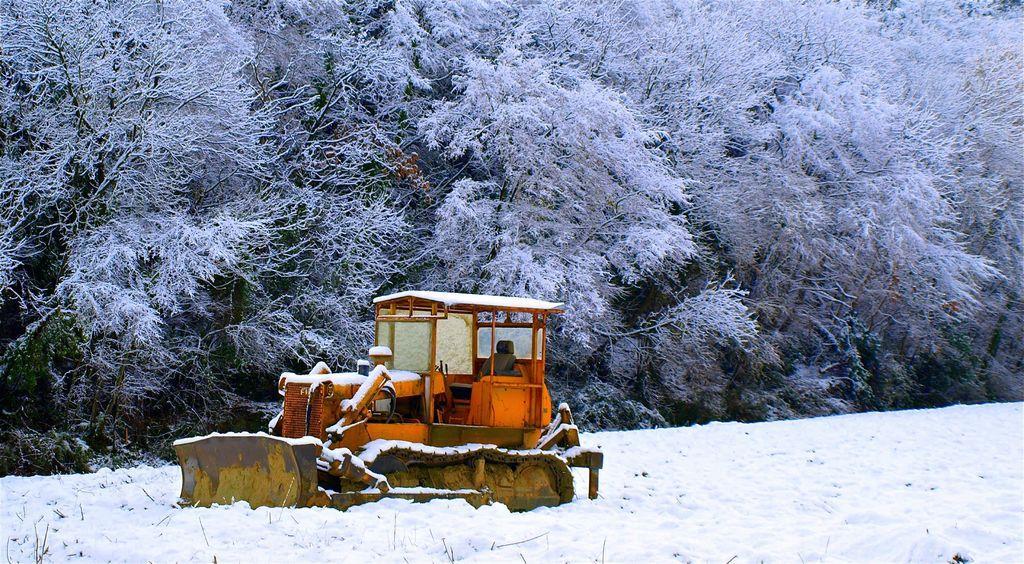How would you summarize this image in a sentence or two? In this picture I can see a bulldozer in the middle, there is the snow. In the background there are trees. 